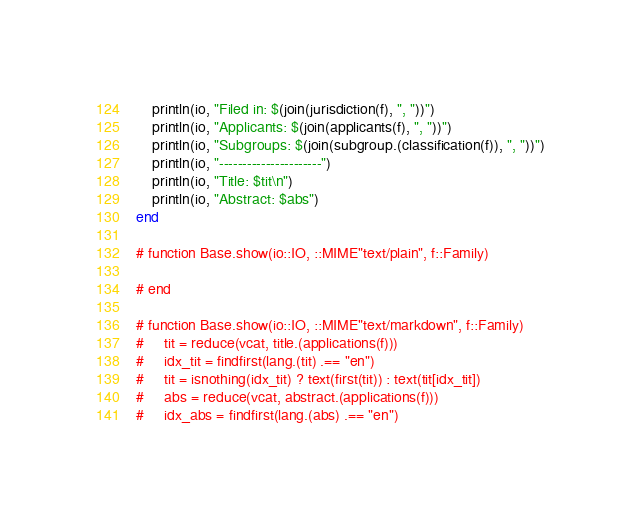Convert code to text. <code><loc_0><loc_0><loc_500><loc_500><_Julia_>    println(io, "Filed in: $(join(jurisdiction(f), ", "))")
    println(io, "Applicants: $(join(applicants(f), ", "))")
    println(io, "Subgroups: $(join(subgroup.(classification(f)), ", "))")
    println(io, "----------------------")
    println(io, "Title: $tit\n")
    println(io, "Abstract: $abs")
end

# function Base.show(io::IO, ::MIME"text/plain", f::Family) 

# end

# function Base.show(io::IO, ::MIME"text/markdown", f::Family) 
#     tit = reduce(vcat, title.(applications(f)))
#     idx_tit = findfirst(lang.(tit) .== "en")
#     tit = isnothing(idx_tit) ? text(first(tit)) : text(tit[idx_tit])
#     abs = reduce(vcat, abstract.(applications(f)))
#     idx_abs = findfirst(lang.(abs) .== "en")</code> 